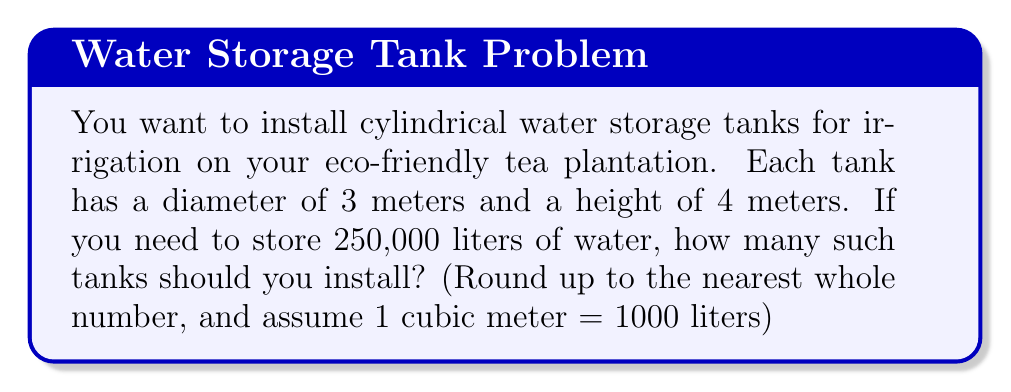Give your solution to this math problem. Let's approach this step-by-step:

1) First, we need to calculate the volume of one cylindrical tank:
   The volume of a cylinder is given by the formula: $V = \pi r^2 h$
   Where $r$ is the radius and $h$ is the height.

2) The diameter is 3 meters, so the radius is 1.5 meters.
   Height is 4 meters.

3) Let's calculate the volume:
   $V = \pi (1.5\text{ m})^2 (4\text{ m})$
   $V = \pi (2.25\text{ m}^2) (4\text{ m})$
   $V = 9\pi\text{ m}^3$

4) Now, let's calculate the exact value:
   $V \approx 28.27\text{ m}^3$

5) Convert this to liters:
   $28.27\text{ m}^3 \times 1000\text{ L/m}^3 = 28,270\text{ L}$

6) To find the number of tanks needed, divide the total water needed by the capacity of one tank:
   $\text{Number of tanks} = \frac{250,000\text{ L}}{28,270\text{ L}} \approx 8.84$

7) Since we can't have a fraction of a tank, we round up to the nearest whole number.
Answer: 9 tanks 